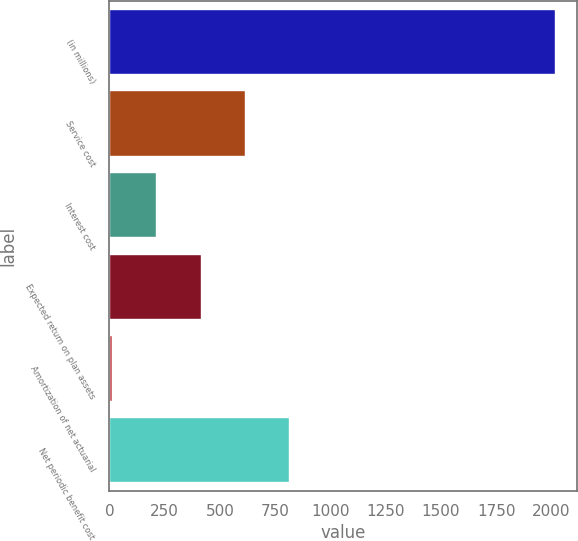Convert chart. <chart><loc_0><loc_0><loc_500><loc_500><bar_chart><fcel>(in millions)<fcel>Service cost<fcel>Interest cost<fcel>Expected return on plan assets<fcel>Amortization of net actuarial<fcel>Net periodic benefit cost<nl><fcel>2015<fcel>612.9<fcel>212.3<fcel>412.6<fcel>12<fcel>813.2<nl></chart> 